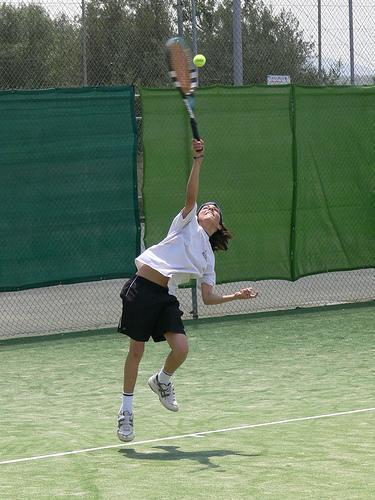How many hands are holding the tennis racket?
Give a very brief answer. 1. How many rolls of white toilet paper are in the bathroom?
Give a very brief answer. 0. 